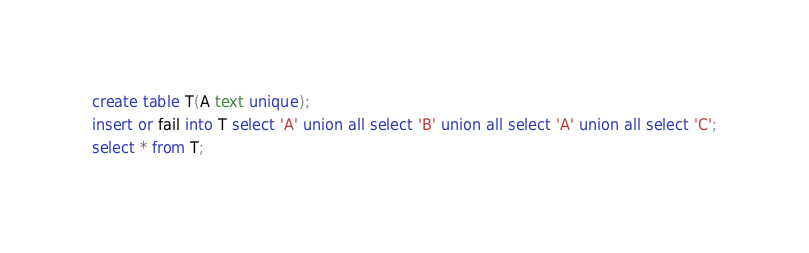<code> <loc_0><loc_0><loc_500><loc_500><_SQL_>create table T(A text unique);
insert or fail into T select 'A' union all select 'B' union all select 'A' union all select 'C';
select * from T;

</code> 